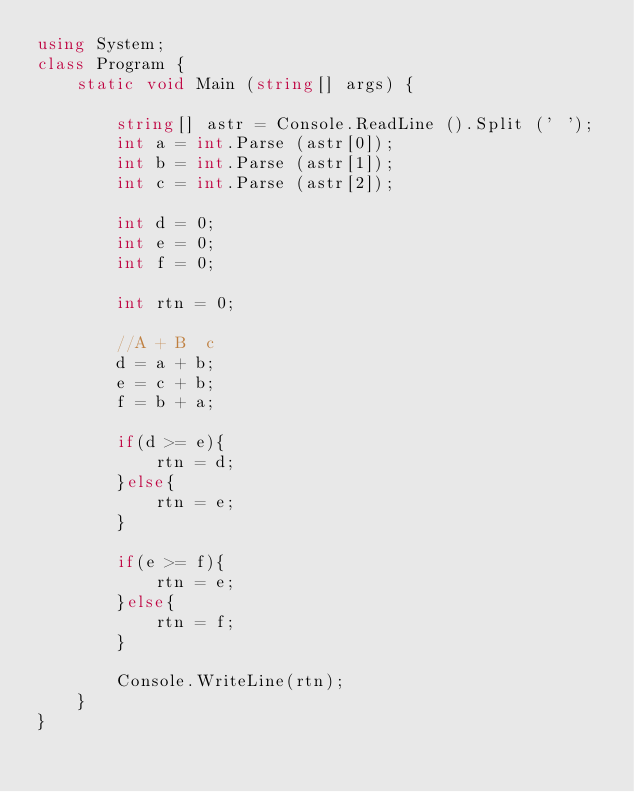Convert code to text. <code><loc_0><loc_0><loc_500><loc_500><_C#_>using System;
class Program {
    static void Main (string[] args) {
        
        string[] astr = Console.ReadLine ().Split (' ');
        int a = int.Parse (astr[0]);
        int b = int.Parse (astr[1]);
        int c = int.Parse (astr[2]);

        int d = 0;
        int e = 0;
        int f = 0;

        int rtn = 0;
        
        //A + B  c
        d = a + b;
        e = c + b;
        f = b + a;

        if(d >= e){
            rtn = d;
        }else{
            rtn = e;
        }

        if(e >= f){
            rtn = e;
        }else{
            rtn = f;
        }
        
        Console.WriteLine(rtn);
    }
}</code> 